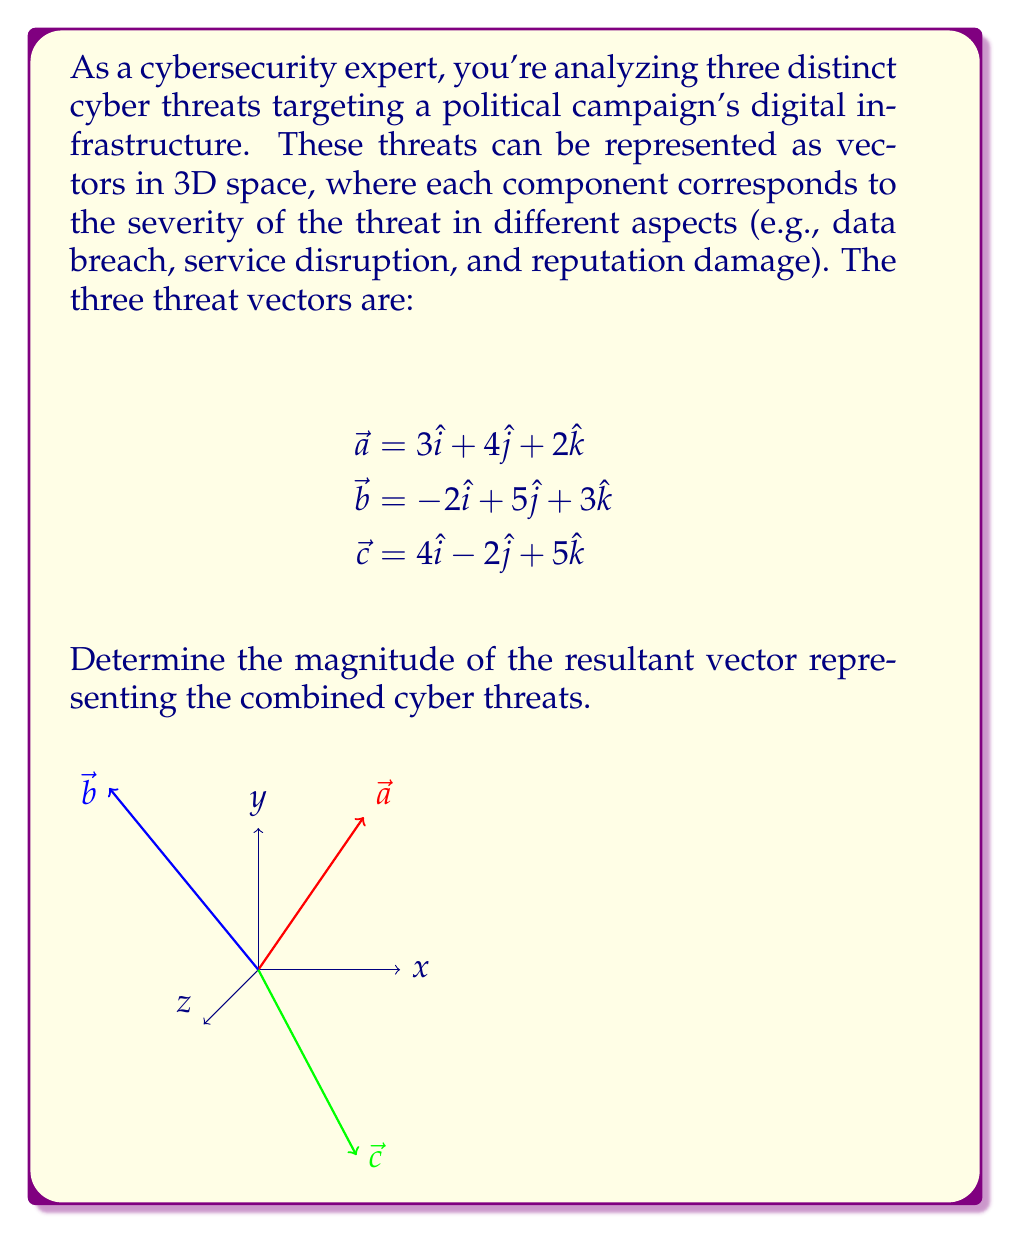Solve this math problem. To solve this problem, we need to follow these steps:

1) First, we need to find the resultant vector by adding the three threat vectors:

   $$\vec{r} = \vec{a} + \vec{b} + \vec{c}$$

2) Let's add the components:

   $$\vec{r} = (3-2+4)\hat{i} + (4+5-2)\hat{j} + (2+3+5)\hat{k}$$
   $$\vec{r} = 5\hat{i} + 7\hat{j} + 10\hat{k}$$

3) Now that we have the resultant vector, we need to calculate its magnitude. The magnitude of a vector $\vec{v} = a\hat{i} + b\hat{j} + c\hat{k}$ is given by:

   $$|\vec{v}| = \sqrt{a^2 + b^2 + c^2}$$

4) Let's substitute our values:

   $$|\vec{r}| = \sqrt{5^2 + 7^2 + 10^2}$$

5) Simplify:

   $$|\vec{r}| = \sqrt{25 + 49 + 100}$$
   $$|\vec{r}| = \sqrt{174}$$

6) Simplify the square root:

   $$|\vec{r}| = \sqrt{174} \approx 13.19$$

Therefore, the magnitude of the resultant vector representing the combined cyber threats is approximately 13.19 units.
Answer: $\sqrt{174}$ or approximately 13.19 units 